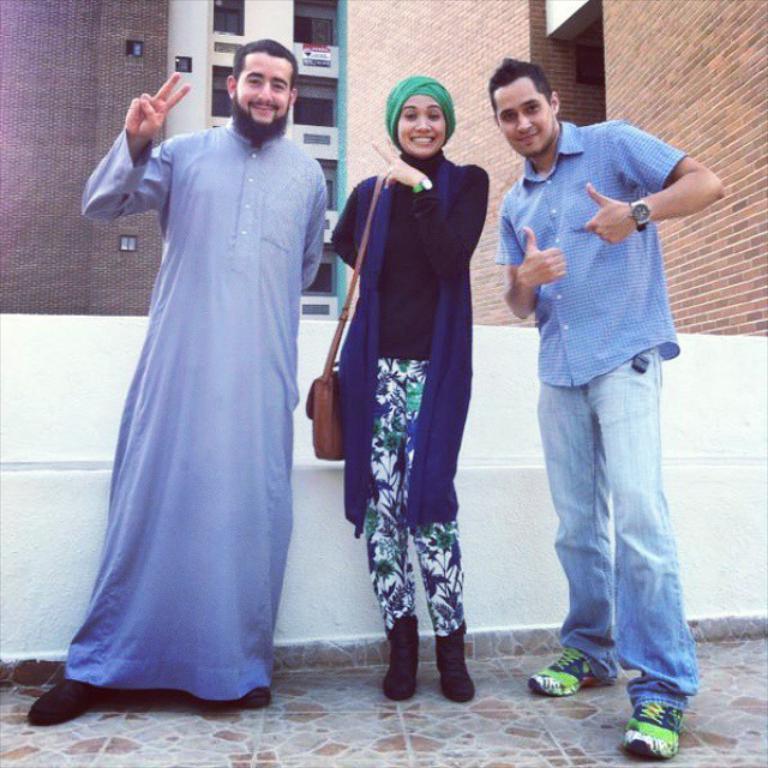Please provide a concise description of this image. This image is taken outdoors. At the bottom of the there is a floor. In the background there are a few buildings with walls, windows and balconies. In the middle of the image two men and a woman are standing on the floor and they are with smiling faces. 